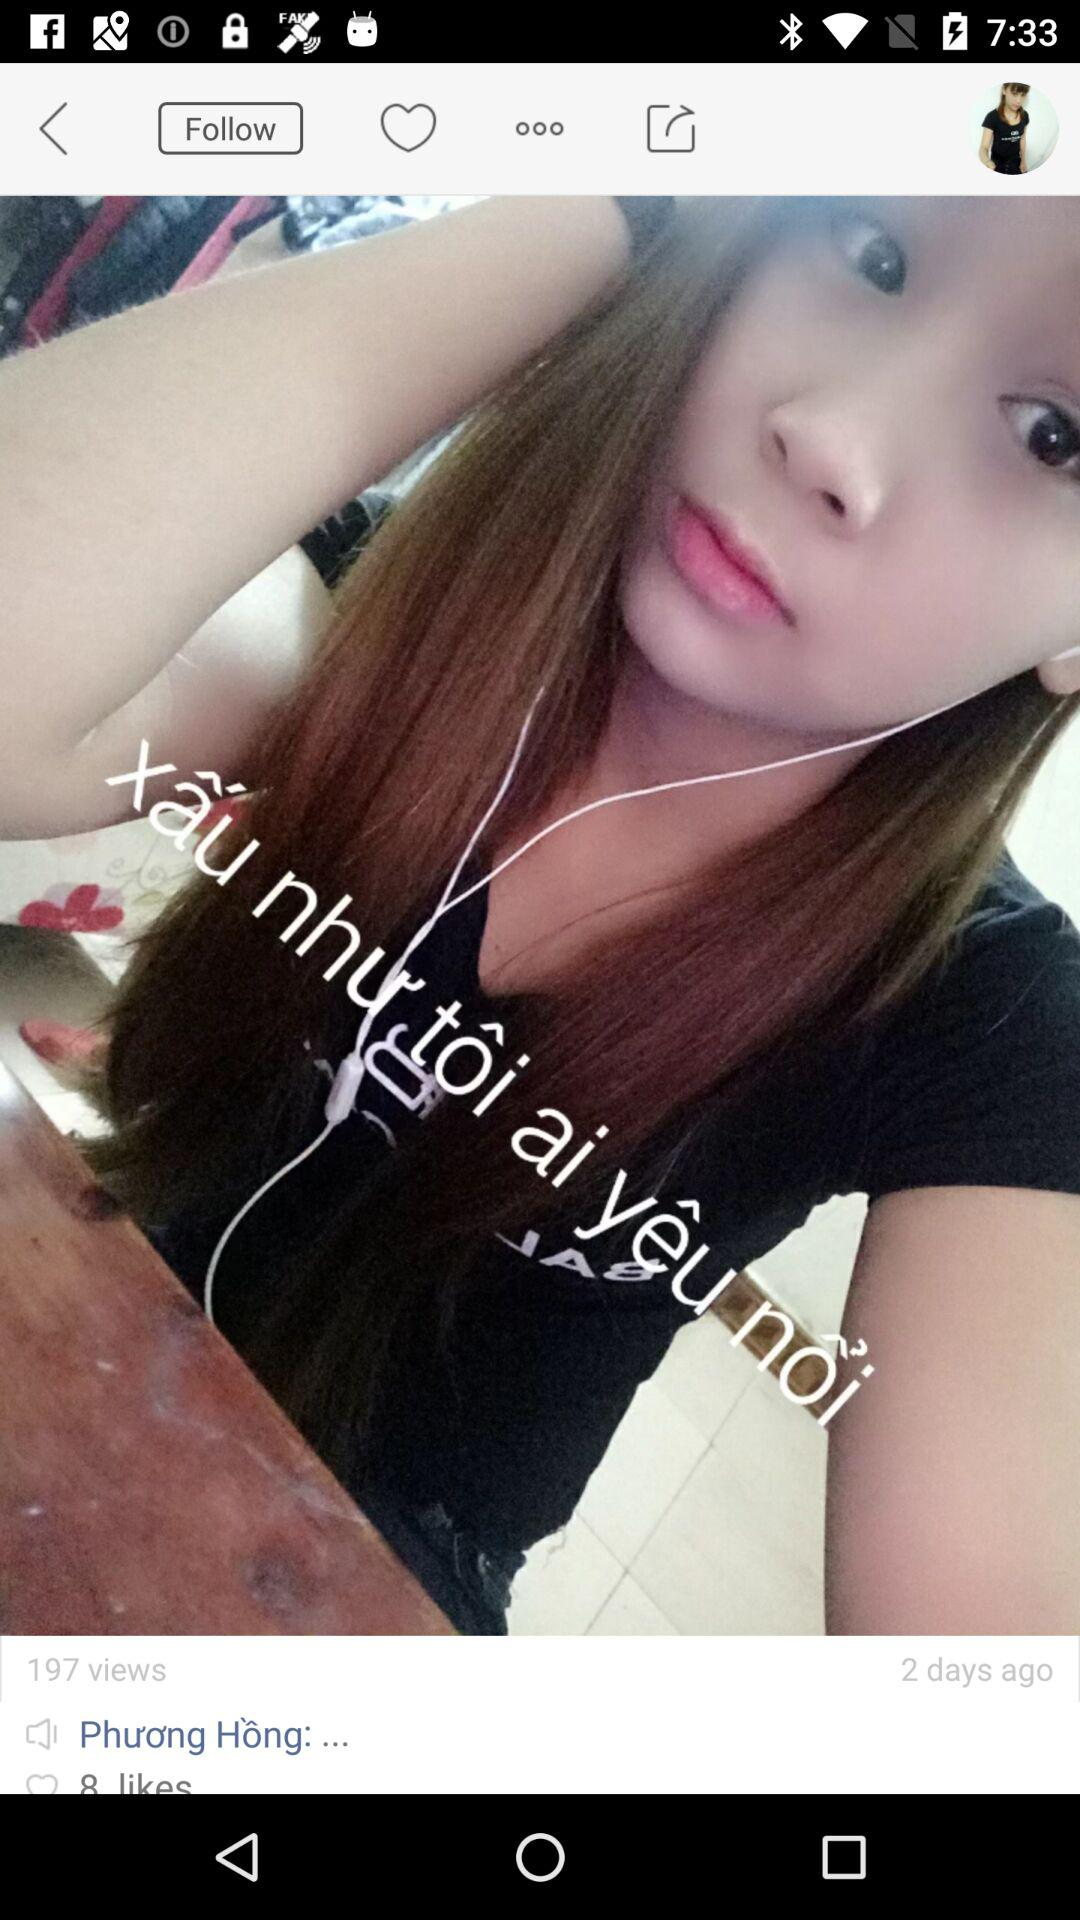What is the count of views? The count is 197. 